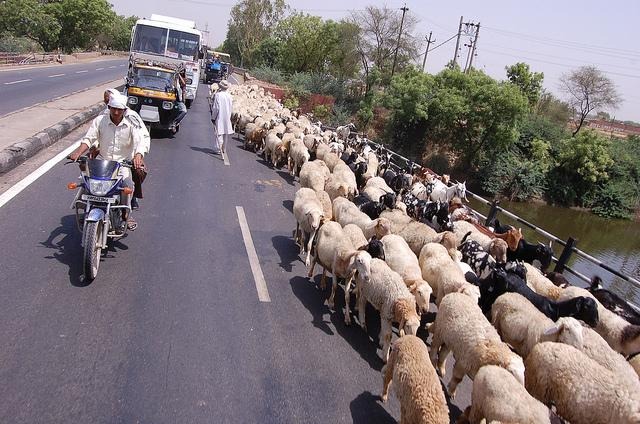What is clogging up the street?

Choices:
A) snow
B) mud
C) eggs
D) animals animals 